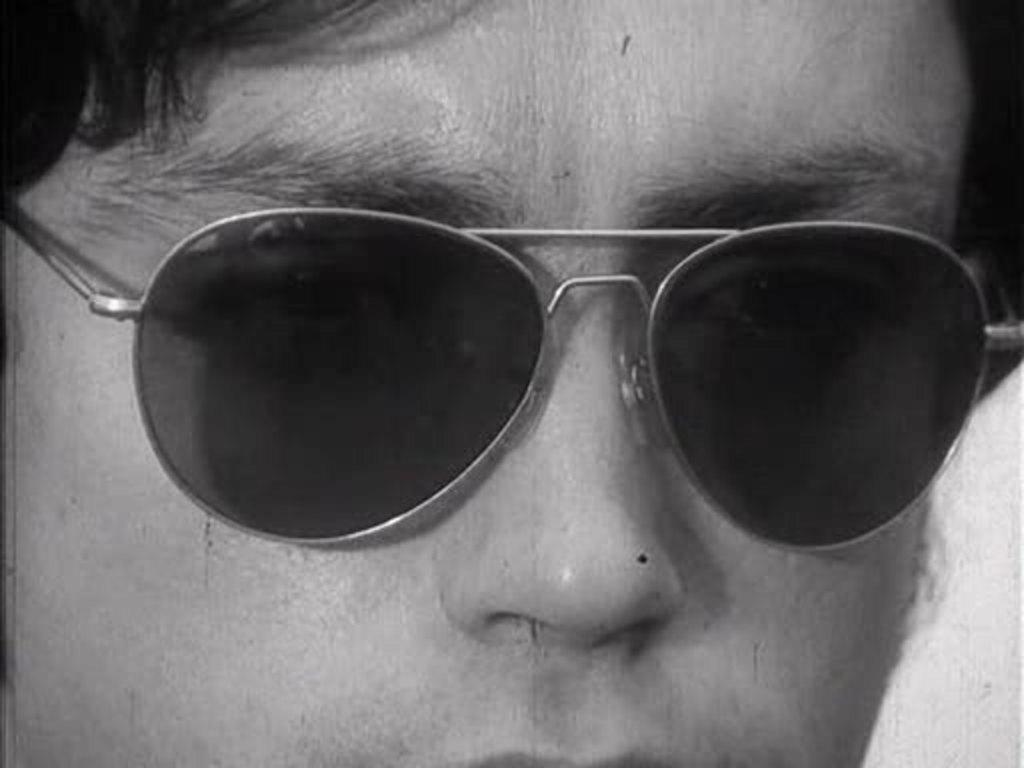Who is the main subject in the image? There is a boy in the image. What is the boy wearing in the image? The boy is wearing black sunglasses. Where is the box located in the image? There is no box present in the image. What direction is the boy facing in the image? The provided facts do not mention the direction the boy is facing, so it cannot be determined from the image. 